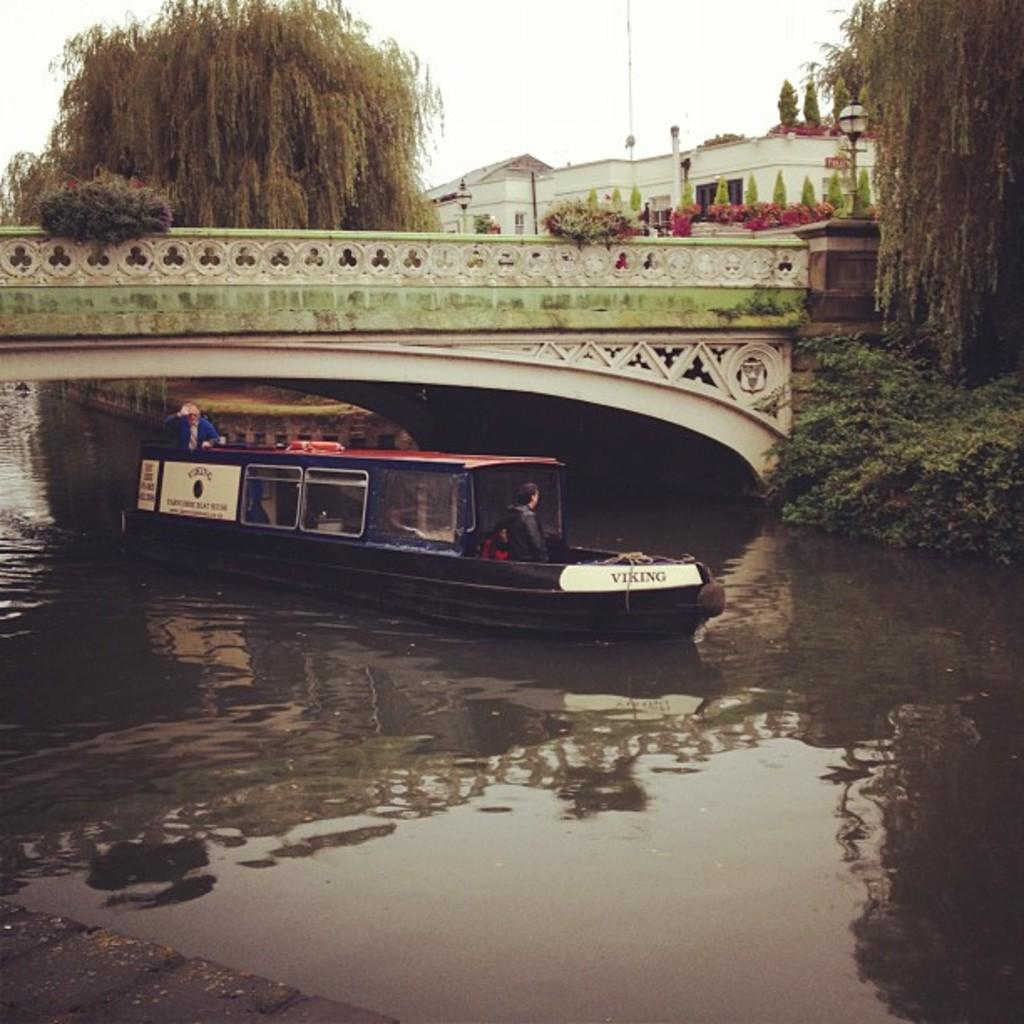What is in the water in the image? There is a boat in the water in the image. Who or what is inside the boat? There are people seated in the boat. What is above the water in the image? There is a bridge over the water in the image. What can be seen in the distance in the image? Trees and buildings are visible in the background of the image. Where is the cart carrying the cub in the image? There is no cart or cub present in the image. What type of train can be seen passing by in the image? There is no train visible in the image. 